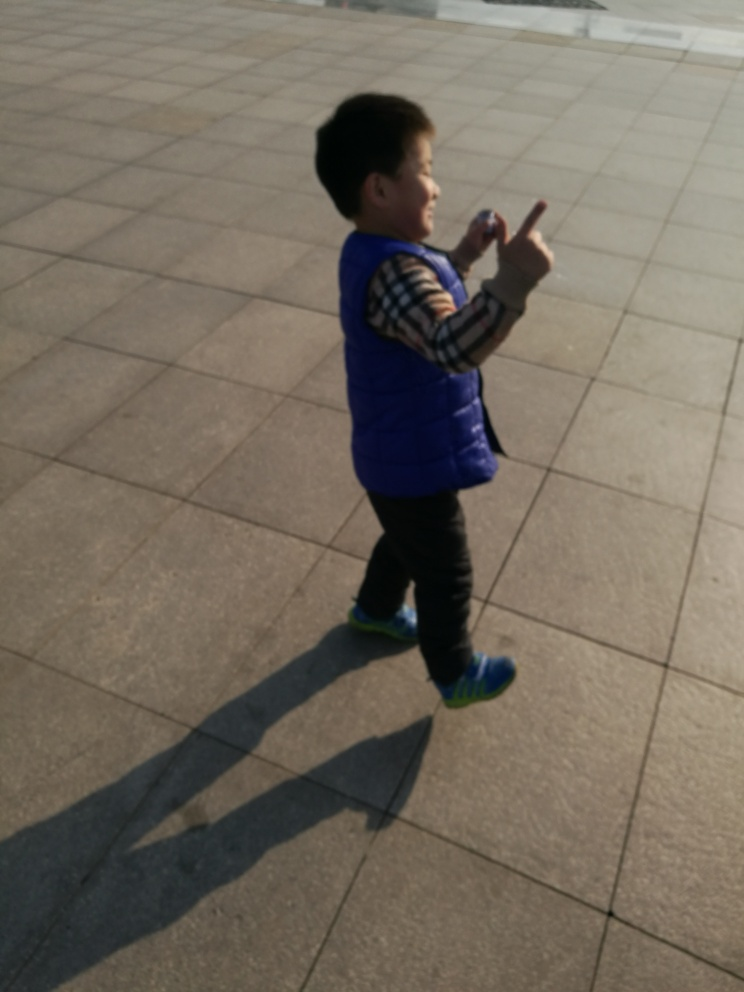Are there any quality issues with this image? Yes, the image appears to be slightly blurred, particularly around the moving subject, indicating motion blur. Additionally, the image is not well-framed, as the subject is not centered, and there is unused space to the left and right. The lighting conditions are harsh, resulting in strong shadows and potentially overexposed areas. 